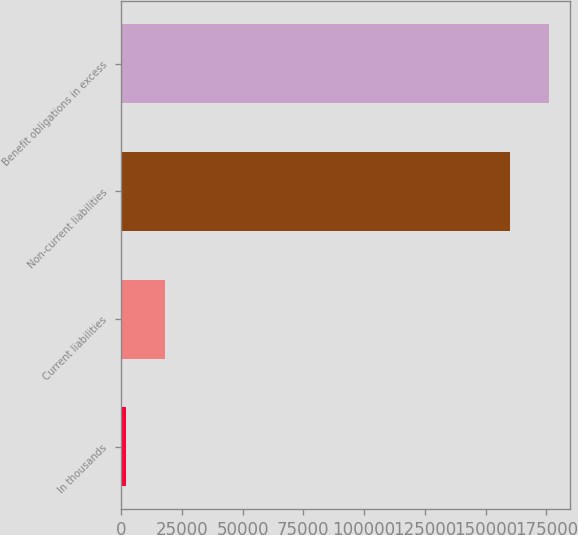Convert chart. <chart><loc_0><loc_0><loc_500><loc_500><bar_chart><fcel>In thousands<fcel>Current liabilities<fcel>Non-current liabilities<fcel>Benefit obligations in excess<nl><fcel>2011<fcel>18133<fcel>159928<fcel>176050<nl></chart> 